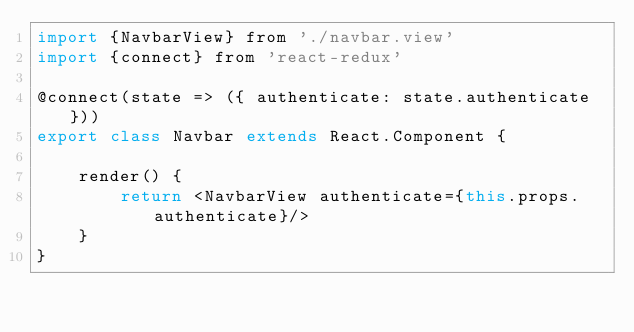Convert code to text. <code><loc_0><loc_0><loc_500><loc_500><_JavaScript_>import {NavbarView} from './navbar.view'
import {connect} from 'react-redux'

@connect(state => ({ authenticate: state.authenticate}))
export class Navbar extends React.Component {

    render() {
        return <NavbarView authenticate={this.props.authenticate}/>
    }
}
</code> 